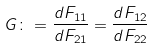<formula> <loc_0><loc_0><loc_500><loc_500>G \colon = \frac { d F _ { 1 1 } } { d F _ { 2 1 } } = \frac { d F _ { 1 2 } } { d F _ { 2 2 } }</formula> 